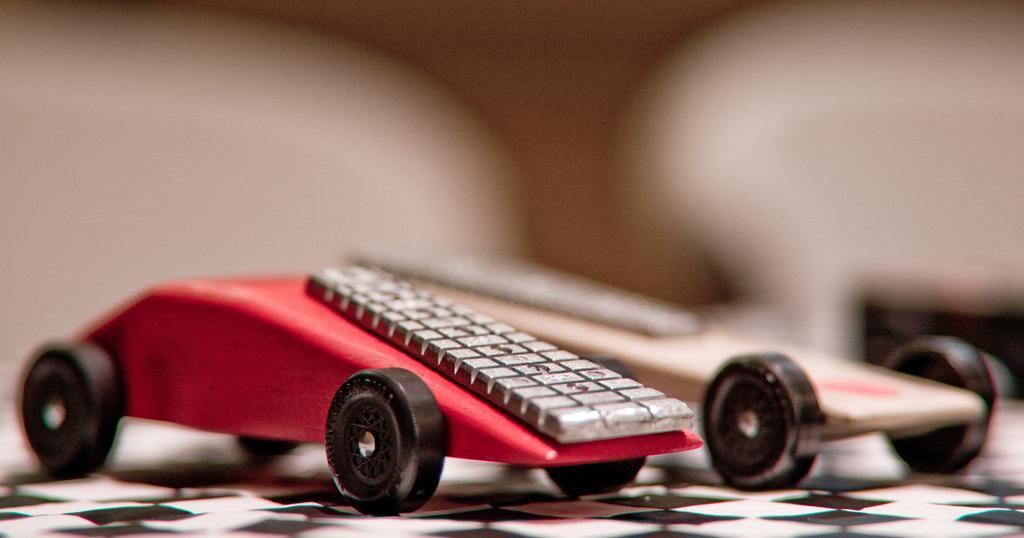Can you describe this image briefly? In this image we can see two toys with wheels are placed on the surface. 